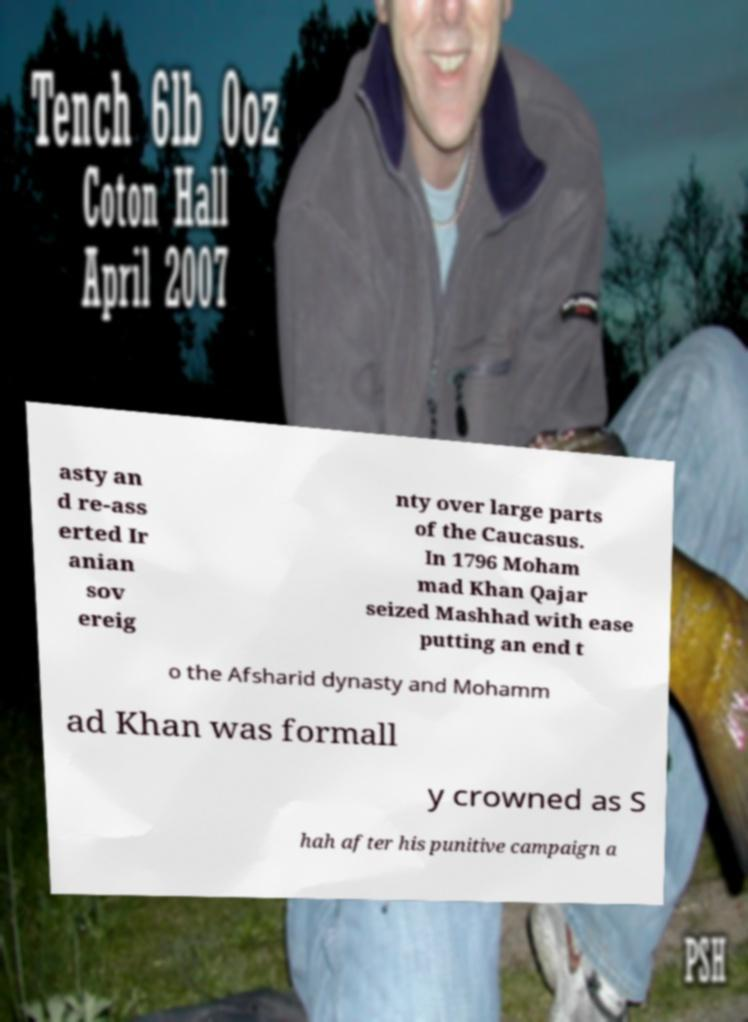Can you accurately transcribe the text from the provided image for me? asty an d re-ass erted Ir anian sov ereig nty over large parts of the Caucasus. In 1796 Moham mad Khan Qajar seized Mashhad with ease putting an end t o the Afsharid dynasty and Mohamm ad Khan was formall y crowned as S hah after his punitive campaign a 